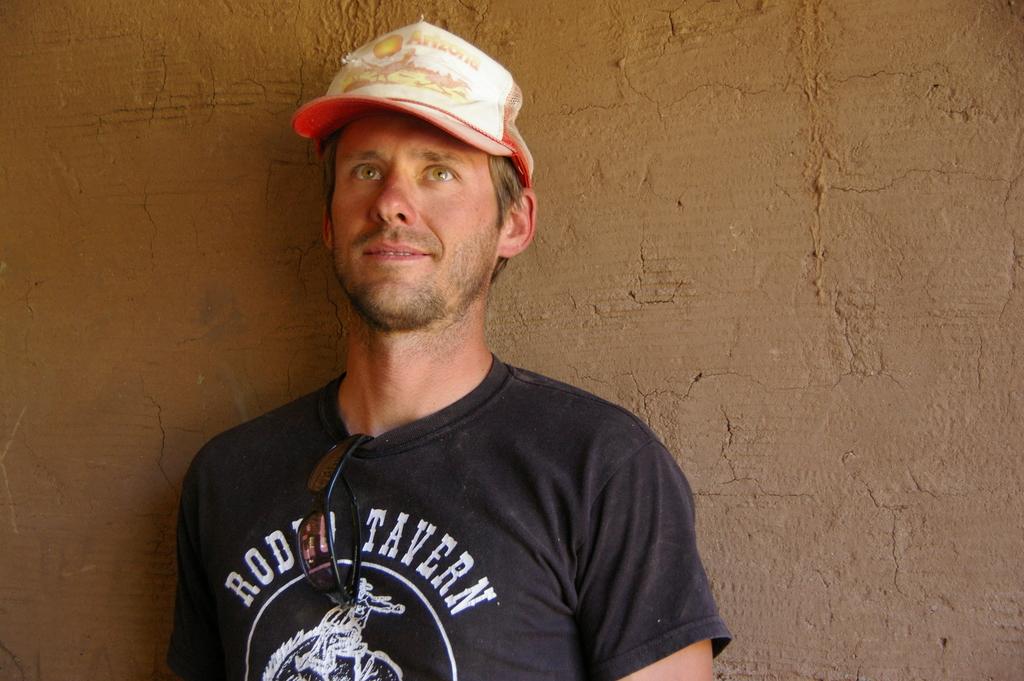What does the guy's shirt say?
Your answer should be very brief. Rodeo tavern. 